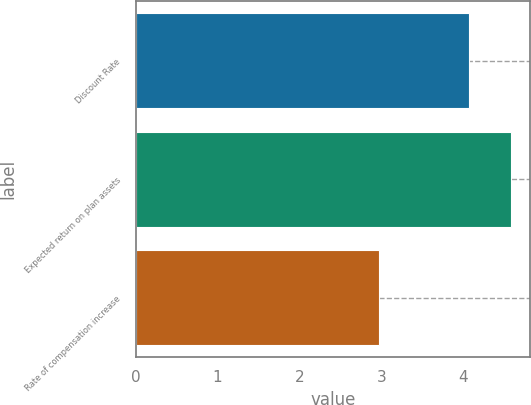<chart> <loc_0><loc_0><loc_500><loc_500><bar_chart><fcel>Discount Rate<fcel>Expected return on plan assets<fcel>Rate of compensation increase<nl><fcel>4.07<fcel>4.59<fcel>2.97<nl></chart> 